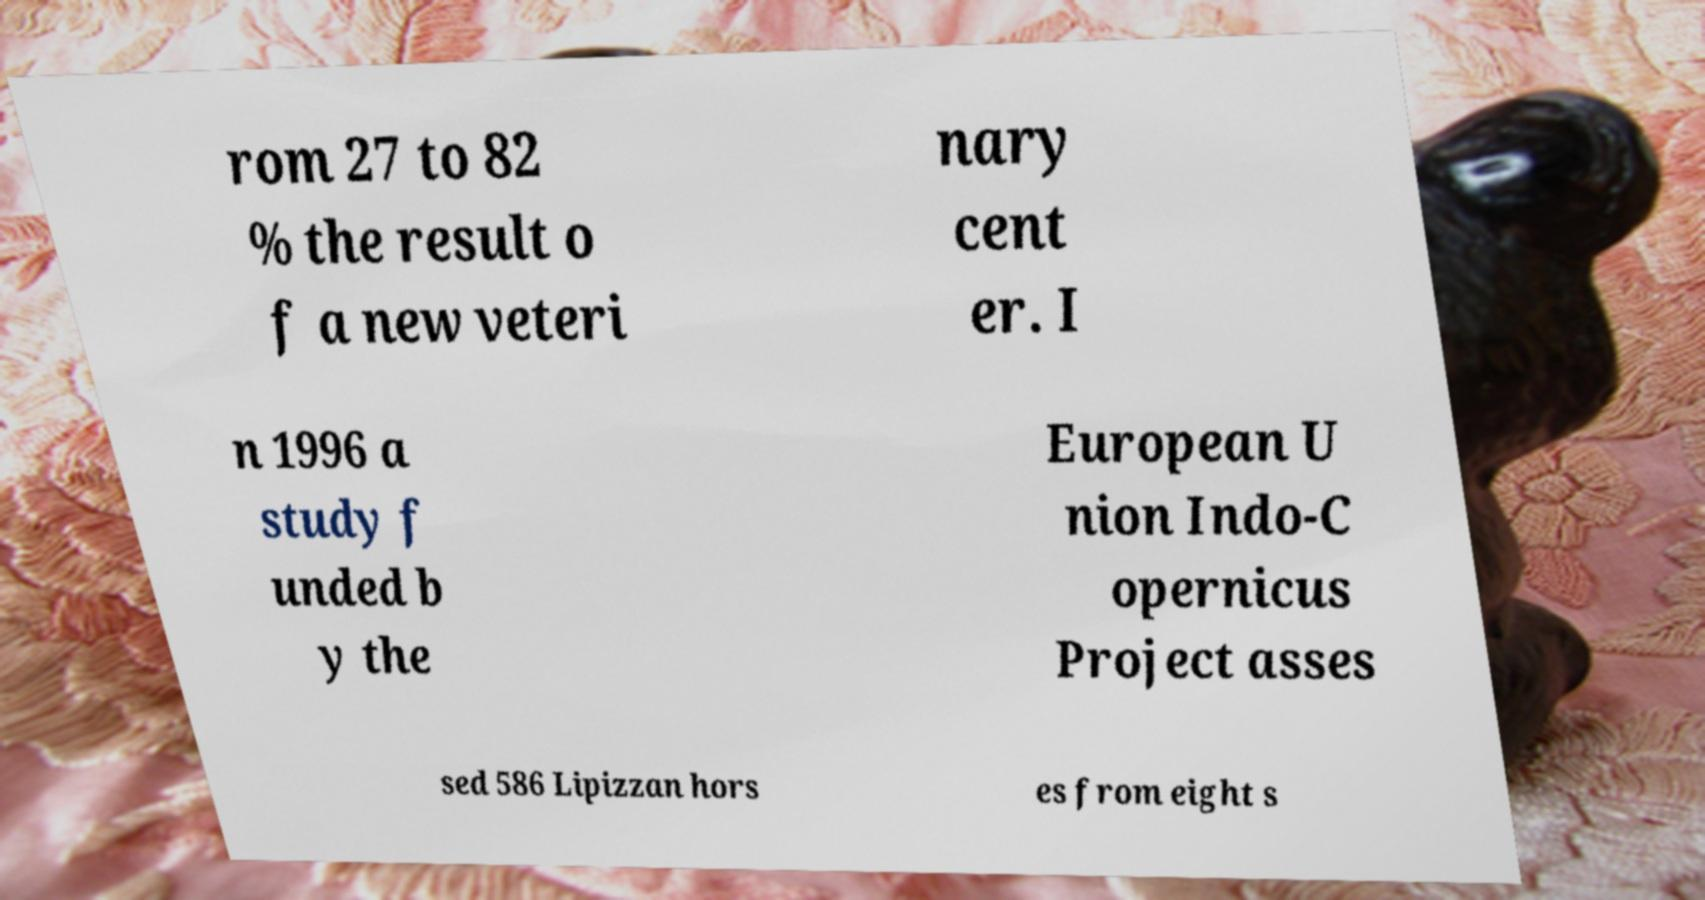Please read and relay the text visible in this image. What does it say? rom 27 to 82 % the result o f a new veteri nary cent er. I n 1996 a study f unded b y the European U nion Indo-C opernicus Project asses sed 586 Lipizzan hors es from eight s 